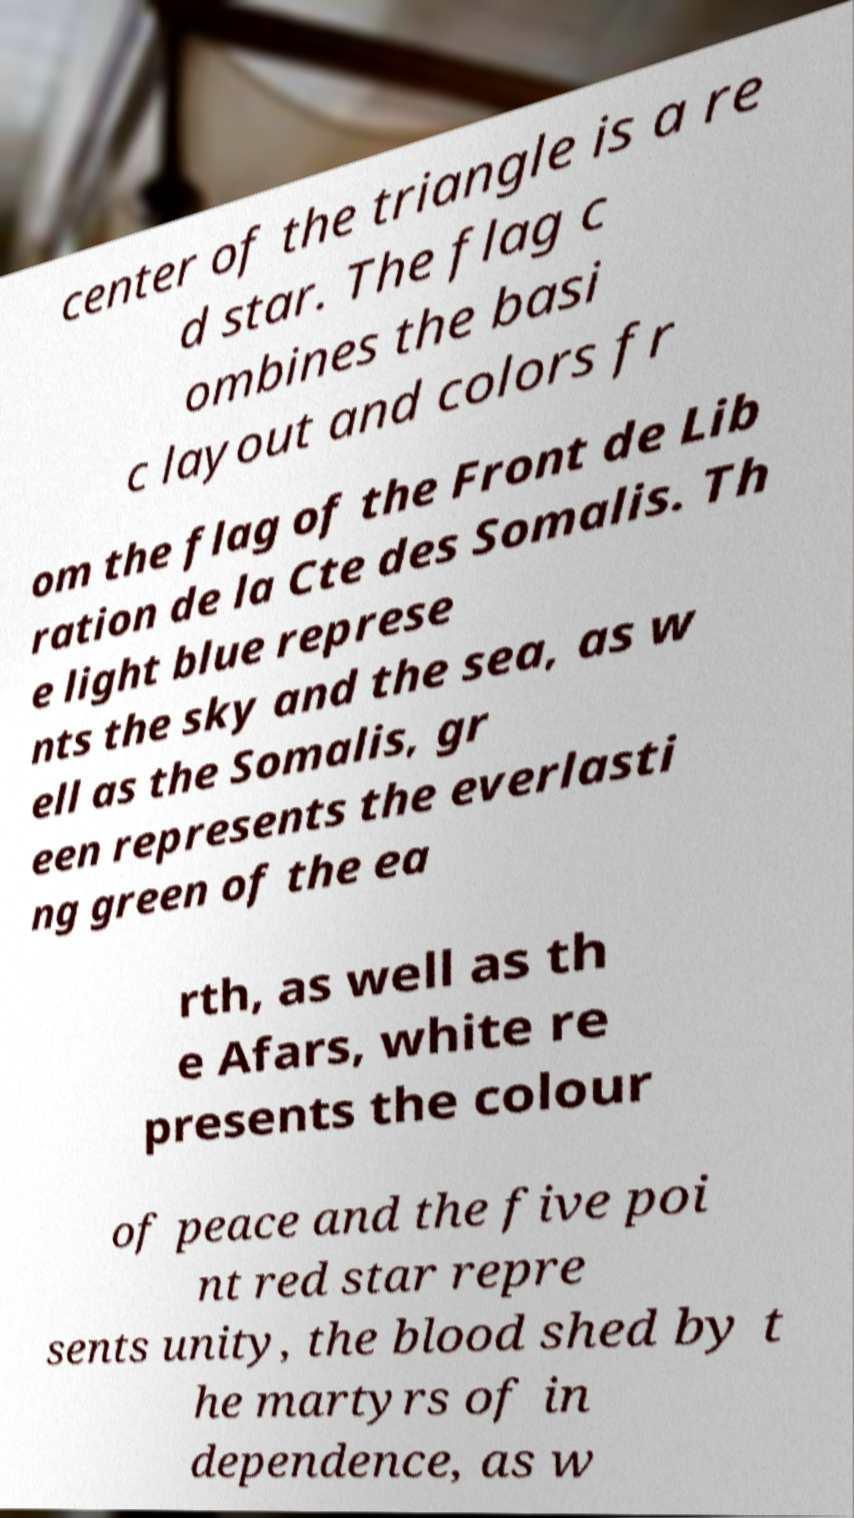Could you extract and type out the text from this image? center of the triangle is a re d star. The flag c ombines the basi c layout and colors fr om the flag of the Front de Lib ration de la Cte des Somalis. Th e light blue represe nts the sky and the sea, as w ell as the Somalis, gr een represents the everlasti ng green of the ea rth, as well as th e Afars, white re presents the colour of peace and the five poi nt red star repre sents unity, the blood shed by t he martyrs of in dependence, as w 